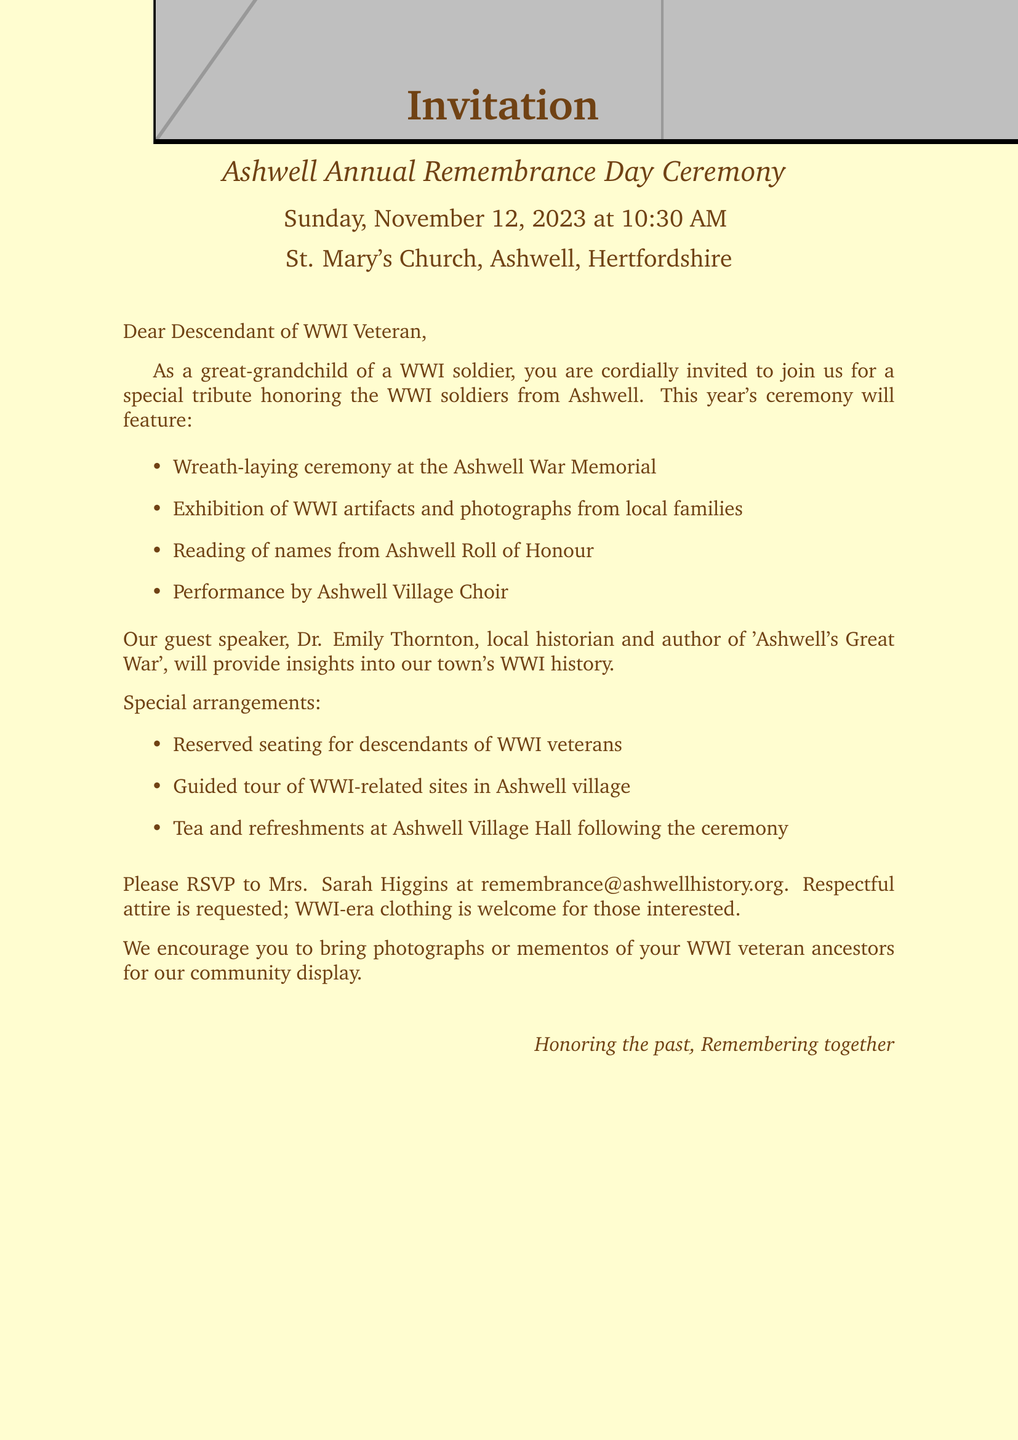What is the name of the event? The event is called the "Ashwell Annual Remembrance Day Ceremony" as stated in the document.
Answer: Ashwell Annual Remembrance Day Ceremony What date is the ceremony taking place? The ceremony is scheduled for Sunday, November 12, 2023, as mentioned in the document.
Answer: November 12, 2023 Who is the guest speaker? The document states that the guest speaker is Dr. Emily Thornton, a local historian.
Answer: Dr. Emily Thornton What is one of the key features of the ceremony? The document lists several key features, one of which is the "Wreath-laying ceremony at the Ashwell War Memorial."
Answer: Wreath-laying ceremony at the Ashwell War Memorial What special arrangement is mentioned for attendees? The document specifies a "Special seating area for descendants of WWI veterans" as a special arrangement.
Answer: Special seating area for descendants of WWI veterans What attire is requested for attendees? The document requests "Respectful attire; WWI-era clothing welcome for those interested" from attendees.
Answer: Respectful attire What activity is planned after the ceremony? Following the ceremony, there will be "Tea and refreshments at Ashwell Village Hall" as stated in the document.
Answer: Tea and refreshments at Ashwell Village Hall What should attendees bring for the community display? The document encourages attendees to bring "photographs or mementos of their WWI veteran ancestors" for the community display.
Answer: Photographs or mementos of their WWI veteran ancestors 